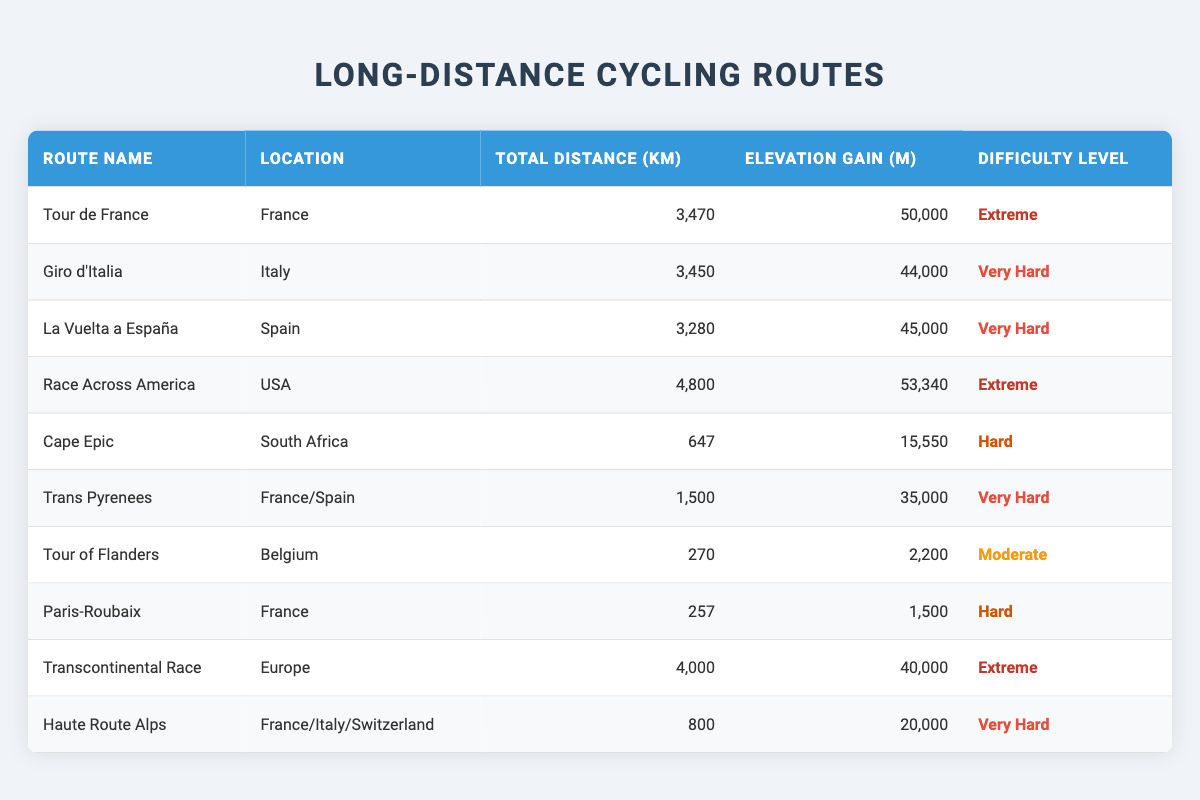What is the total distance of the Race Across America route? The table shows that the total distance for the Race Across America route is listed as 4,800 km. This information can be directly found in the corresponding row under the "Total Distance (km)" column.
Answer: 4,800 km Which route has the highest elevation gain? By examining the "Elevation Gain (m)" column for all routes, the Race Across America has the highest elevation gain of 53,340 m, as shown in its row. This is more than any other value in that column.
Answer: 53,340 m Is there a route with a difficulty level classified as Moderate? Looking through the "Difficulty Level" column, only the Tour of Flanders is marked as Moderate, indicating that there is indeed one route with this classification.
Answer: Yes What is the average distance of routes classified as Extreme? To find the average distance for Extreme routes, we first identify the distances of the three Extreme routes: Tour de France (3,470 km), Race Across America (4,800 km), and Transcontinental Race (4,000 km). We then sum these distances: 3,470 + 4,800 + 4,000 = 12,270 km. There are 3 Extreme routes, so we divide: 12,270 km / 3 = 4,090 km.
Answer: 4,090 km How many routes have a difficulty level of Very Hard? To find out how many routes are classified as Very Hard, we can count the rows where the "Difficulty Level" is "Very Hard." There are four routes: Giro d'Italia, La Vuelta a España, Trans Pyrenees, and Haute Route Alps, making a total of four routes in this category.
Answer: 4 Which route has the lowest elevation gain? By analyzing the "Elevation Gain (m)" column, we find that the Tour of Flanders has the lowest elevation gain listed at 2,200 m, which is the smallest number in that column across all routes.
Answer: 2,200 m How much taller is the highest elevation gain compared to the lowest elevation gain? The highest elevation gain is 53,340 m for the Race Across America, and the lowest is 2,200 m for the Tour of Flanders. To find how much taller it is, we subtract: 53,340 m - 2,200 m = 51,140 m.
Answer: 51,140 m Is the total distance of the Giro d'Italia greater than that of Cape Epic? The total distance of the Giro d'Italia is 3,450 km, while the distance for Cape Epic is 647 km. Since 3,450 km is greater than 647 km, the answer is affirmative.
Answer: Yes What is the difference in elevation gain between the Tour de France and the La Vuelta a España? The elevation gain for the Tour de France is 50,000 m, while for La Vuelta a España, it is 45,000 m. To find the difference, we subtract: 50,000 m - 45,000 m = 5,000 m.
Answer: 5,000 m 